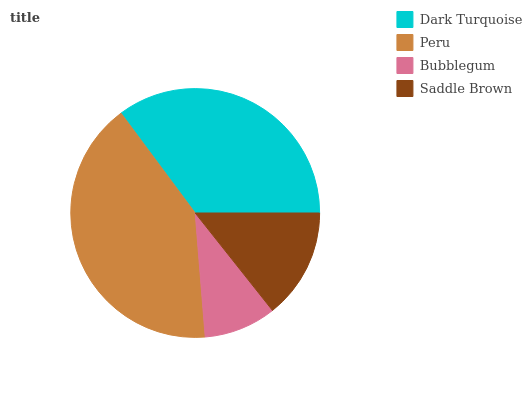Is Bubblegum the minimum?
Answer yes or no. Yes. Is Peru the maximum?
Answer yes or no. Yes. Is Peru the minimum?
Answer yes or no. No. Is Bubblegum the maximum?
Answer yes or no. No. Is Peru greater than Bubblegum?
Answer yes or no. Yes. Is Bubblegum less than Peru?
Answer yes or no. Yes. Is Bubblegum greater than Peru?
Answer yes or no. No. Is Peru less than Bubblegum?
Answer yes or no. No. Is Dark Turquoise the high median?
Answer yes or no. Yes. Is Saddle Brown the low median?
Answer yes or no. Yes. Is Bubblegum the high median?
Answer yes or no. No. Is Peru the low median?
Answer yes or no. No. 